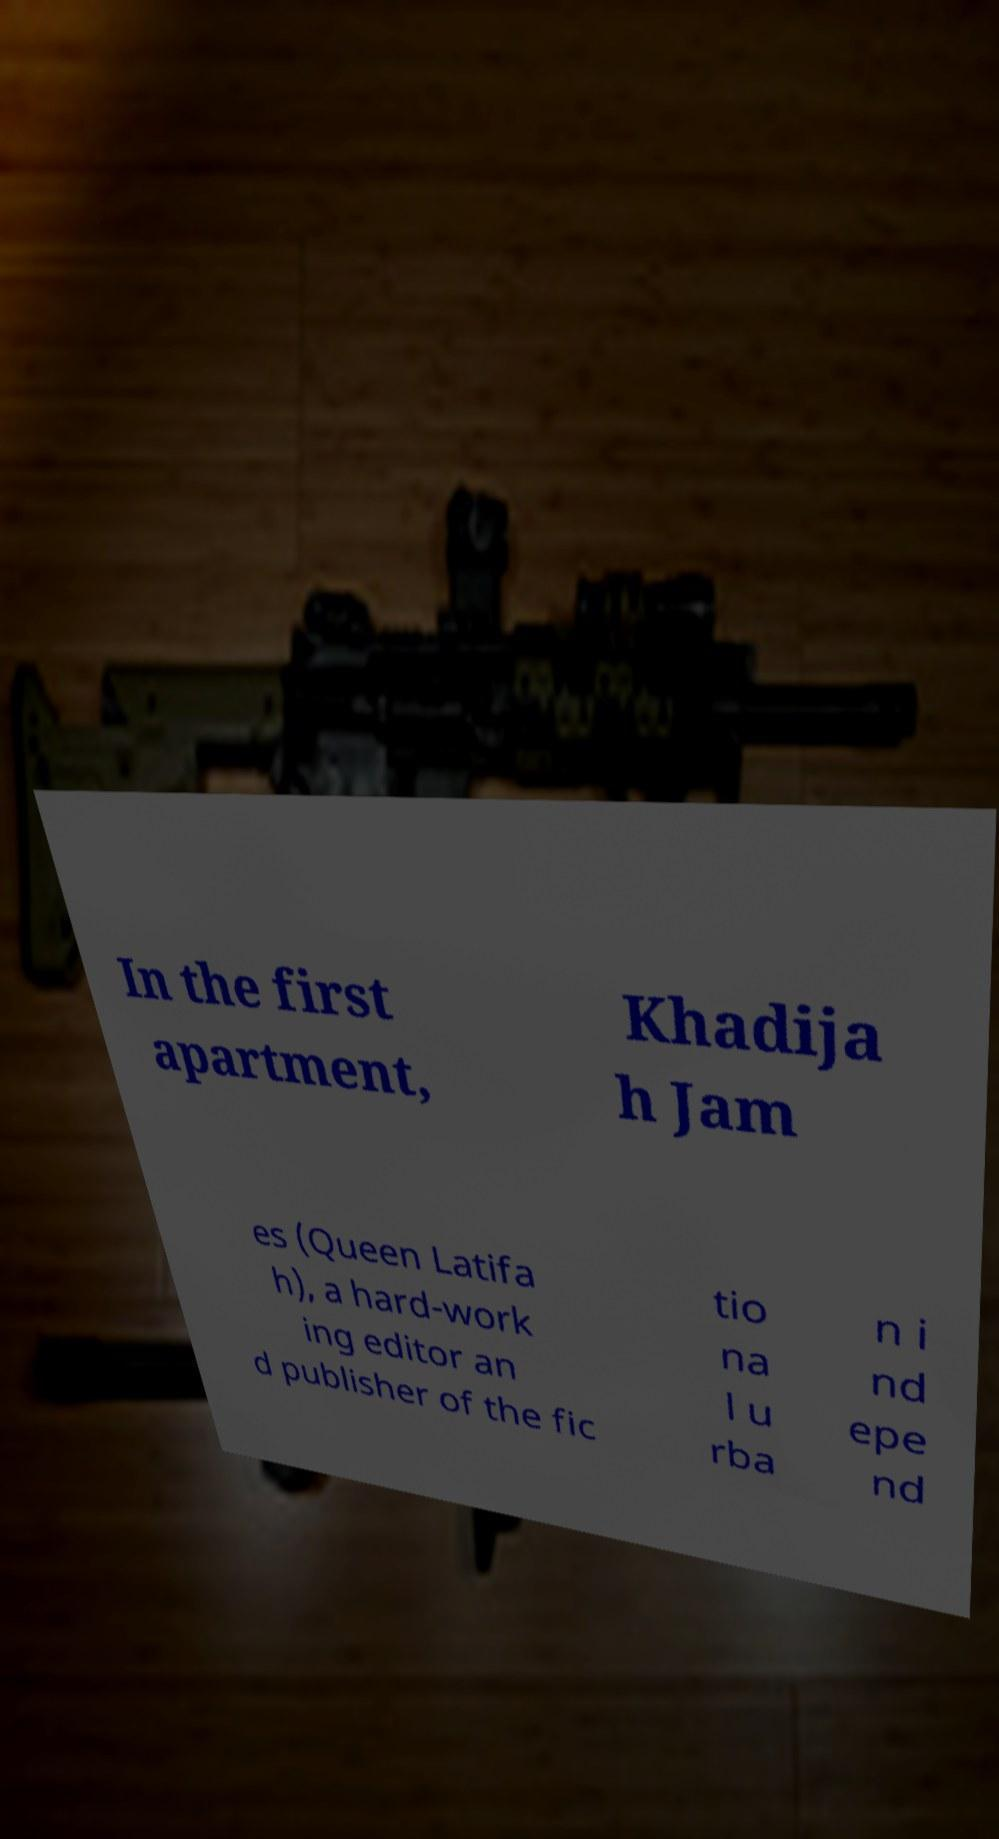Please read and relay the text visible in this image. What does it say? In the first apartment, Khadija h Jam es (Queen Latifa h), a hard-work ing editor an d publisher of the fic tio na l u rba n i nd epe nd 